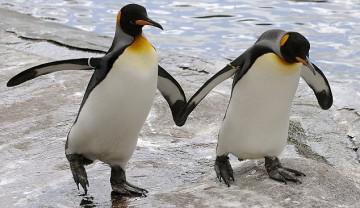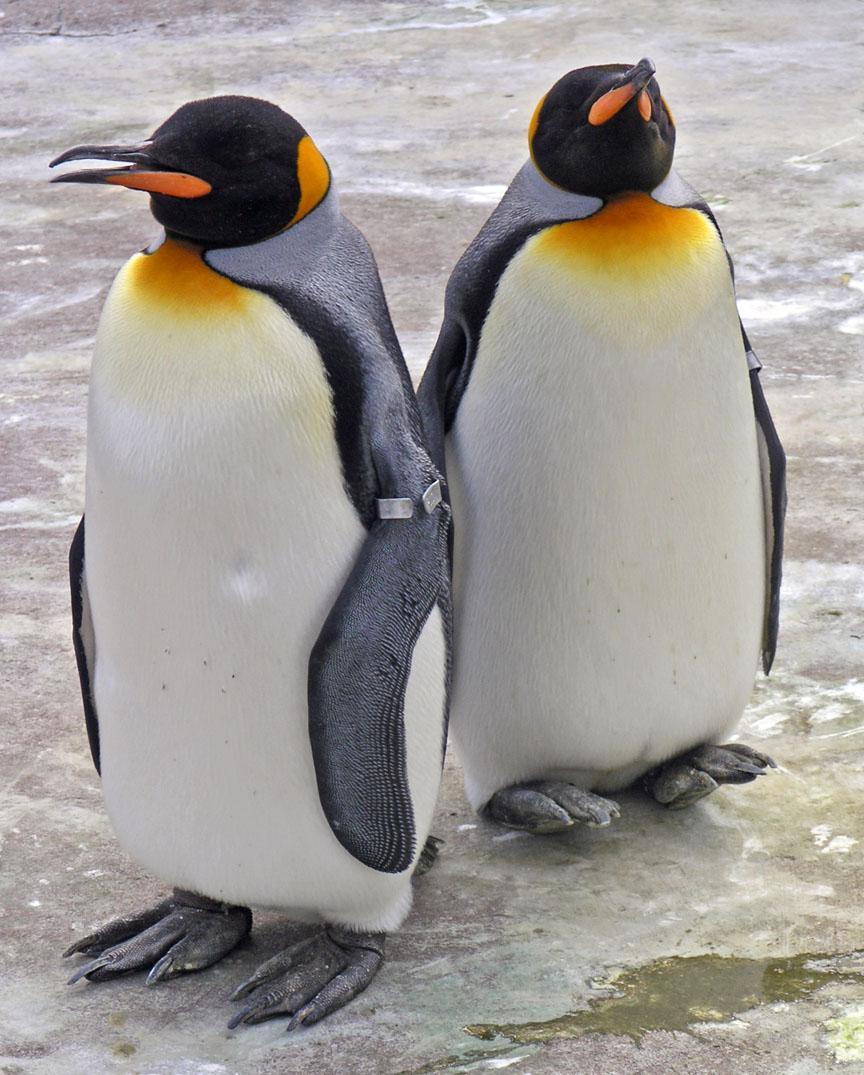The first image is the image on the left, the second image is the image on the right. Assess this claim about the two images: "There are two penguins in the right image.". Correct or not? Answer yes or no. Yes. The first image is the image on the left, the second image is the image on the right. Considering the images on both sides, is "An image shows exactly two penguins who appear to be walking """"hand-in-hand""""." valid? Answer yes or no. Yes. 